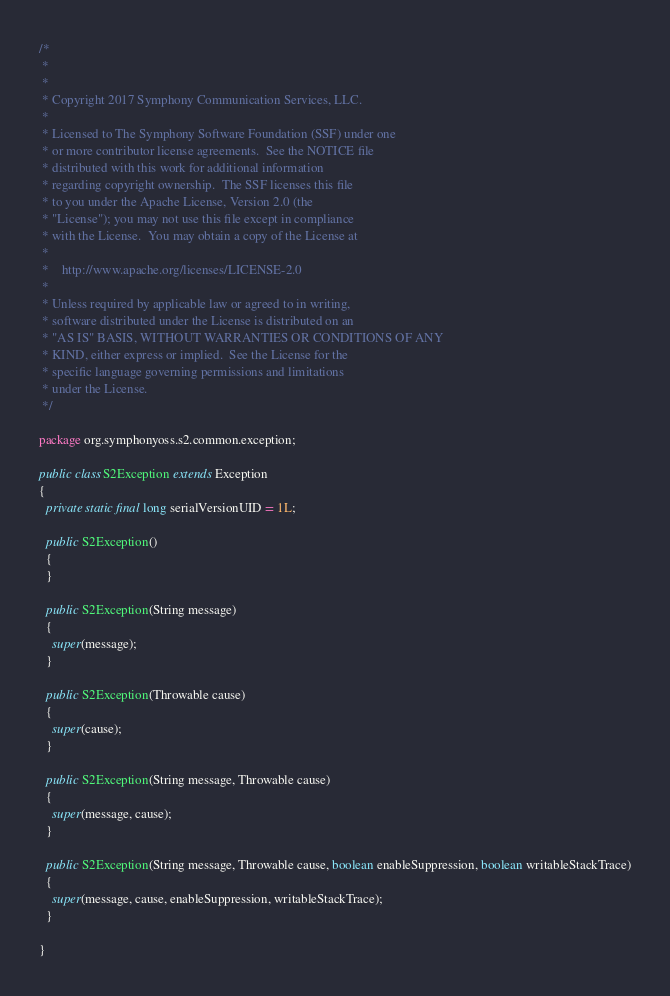<code> <loc_0><loc_0><loc_500><loc_500><_Java_>/*
 *
 *
 * Copyright 2017 Symphony Communication Services, LLC.
 *
 * Licensed to The Symphony Software Foundation (SSF) under one
 * or more contributor license agreements.  See the NOTICE file
 * distributed with this work for additional information
 * regarding copyright ownership.  The SSF licenses this file
 * to you under the Apache License, Version 2.0 (the
 * "License"); you may not use this file except in compliance
 * with the License.  You may obtain a copy of the License at
 *
 *    http://www.apache.org/licenses/LICENSE-2.0
 *
 * Unless required by applicable law or agreed to in writing,
 * software distributed under the License is distributed on an
 * "AS IS" BASIS, WITHOUT WARRANTIES OR CONDITIONS OF ANY
 * KIND, either express or implied.  See the License for the
 * specific language governing permissions and limitations
 * under the License.
 */

package org.symphonyoss.s2.common.exception;

public class S2Exception extends Exception
{
  private static final long serialVersionUID = 1L;

  public S2Exception()
  {
  }

  public S2Exception(String message)
  {
    super(message);
  }

  public S2Exception(Throwable cause)
  {
    super(cause);
  }

  public S2Exception(String message, Throwable cause)
  {
    super(message, cause);
  }

  public S2Exception(String message, Throwable cause, boolean enableSuppression, boolean writableStackTrace)
  {
    super(message, cause, enableSuppression, writableStackTrace);
  }

}
</code> 